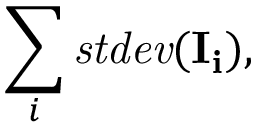Convert formula to latex. <formula><loc_0><loc_0><loc_500><loc_500>\sum _ { i } s t d e v ( I _ { i } ) ,</formula> 